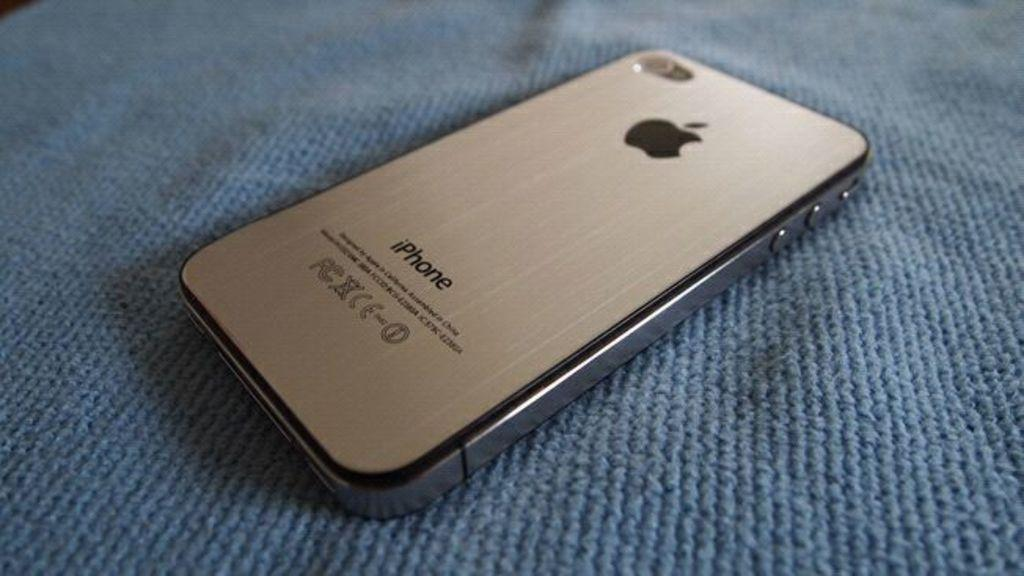<image>
Write a terse but informative summary of the picture. A gray iPhone is placed on it's screen face flat. 